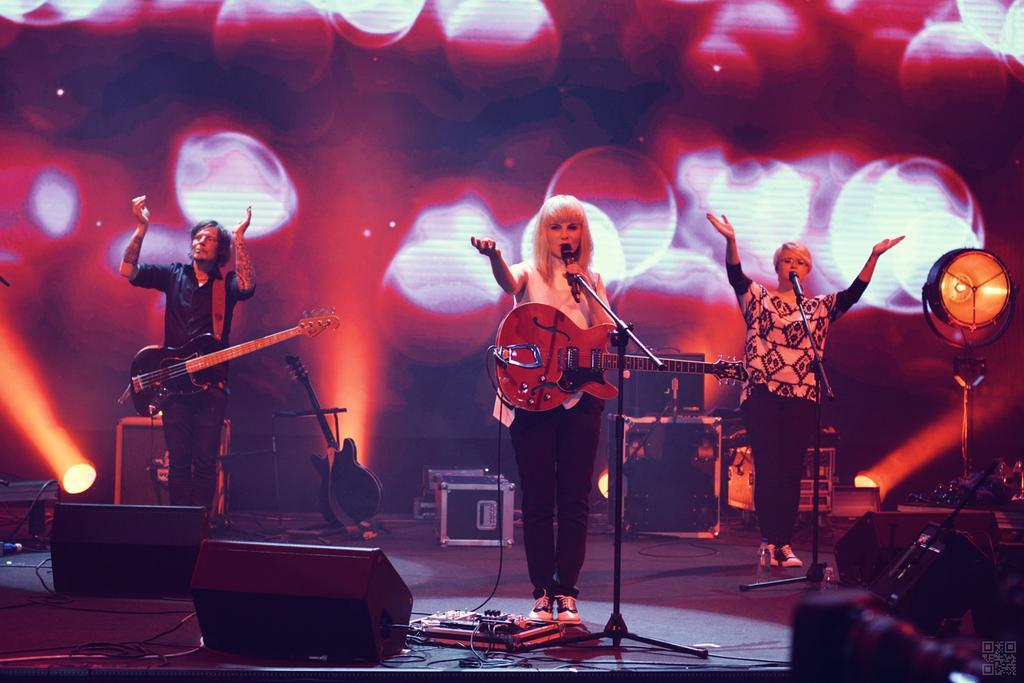Please provide a concise description of this image. It seems to be the image is taken on stage. In image there are three people standing and playing their musical instrument in front of a microphone at bottom there are some speakers,wire and a light in background there is a screen. 